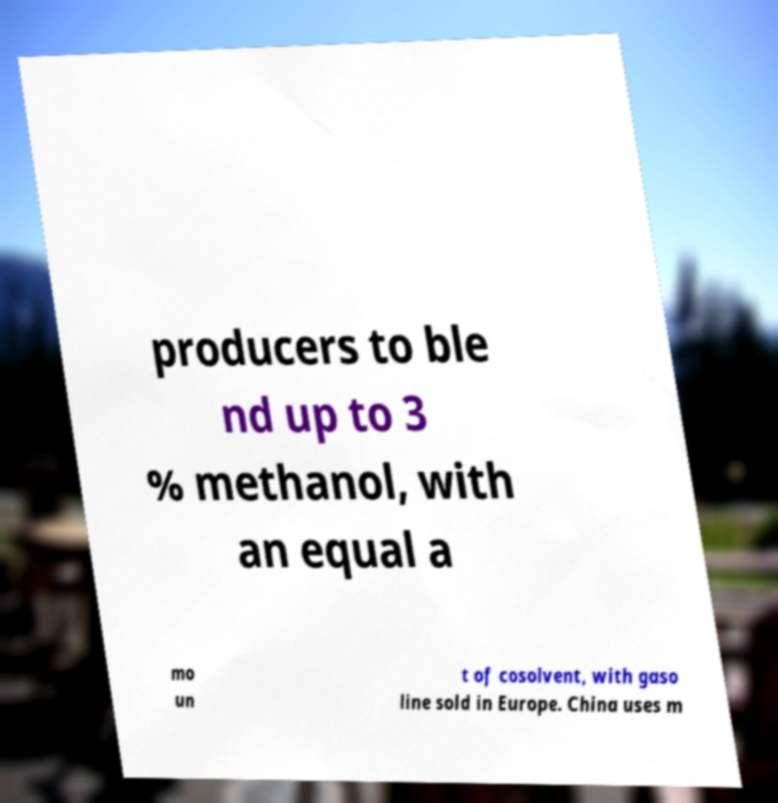There's text embedded in this image that I need extracted. Can you transcribe it verbatim? producers to ble nd up to 3 % methanol, with an equal a mo un t of cosolvent, with gaso line sold in Europe. China uses m 